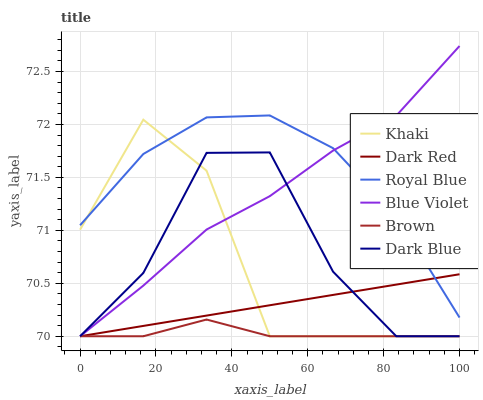Does Brown have the minimum area under the curve?
Answer yes or no. Yes. Does Royal Blue have the maximum area under the curve?
Answer yes or no. Yes. Does Khaki have the minimum area under the curve?
Answer yes or no. No. Does Khaki have the maximum area under the curve?
Answer yes or no. No. Is Dark Red the smoothest?
Answer yes or no. Yes. Is Khaki the roughest?
Answer yes or no. Yes. Is Royal Blue the smoothest?
Answer yes or no. No. Is Royal Blue the roughest?
Answer yes or no. No. Does Brown have the lowest value?
Answer yes or no. Yes. Does Royal Blue have the lowest value?
Answer yes or no. No. Does Blue Violet have the highest value?
Answer yes or no. Yes. Does Khaki have the highest value?
Answer yes or no. No. Is Brown less than Royal Blue?
Answer yes or no. Yes. Is Royal Blue greater than Brown?
Answer yes or no. Yes. Does Royal Blue intersect Blue Violet?
Answer yes or no. Yes. Is Royal Blue less than Blue Violet?
Answer yes or no. No. Is Royal Blue greater than Blue Violet?
Answer yes or no. No. Does Brown intersect Royal Blue?
Answer yes or no. No. 